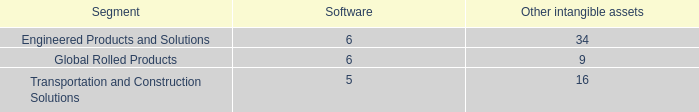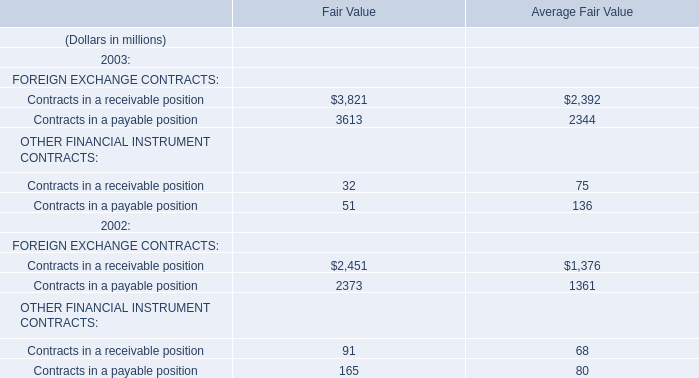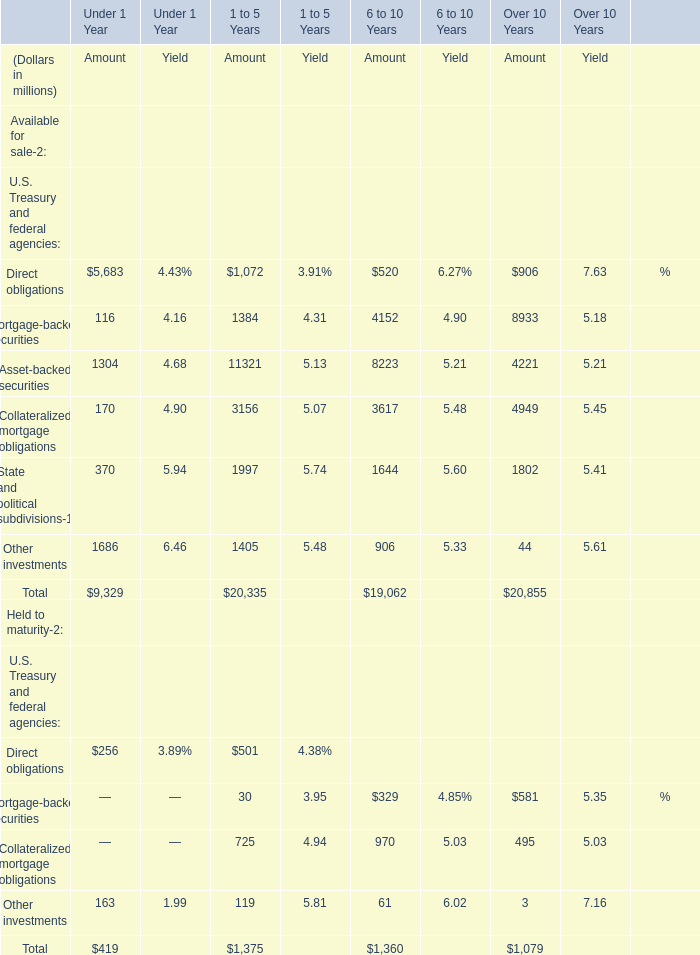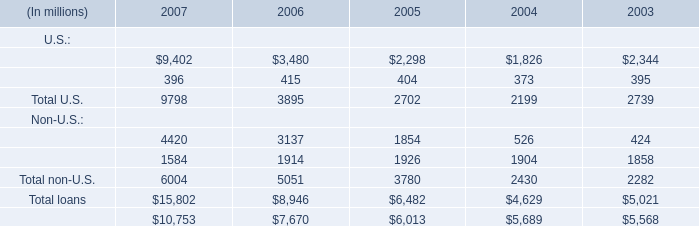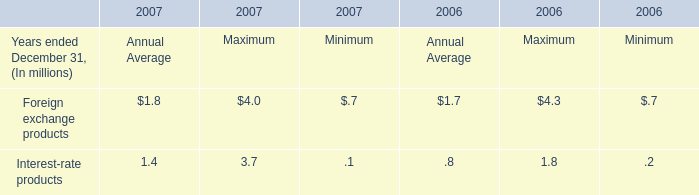What's the average of Other investments of 1 to 5 Years Amount, and Contracts in a payable position of Average Fair Value ? 
Computations: ((1405.0 + 2344.0) / 2)
Answer: 1874.5. 